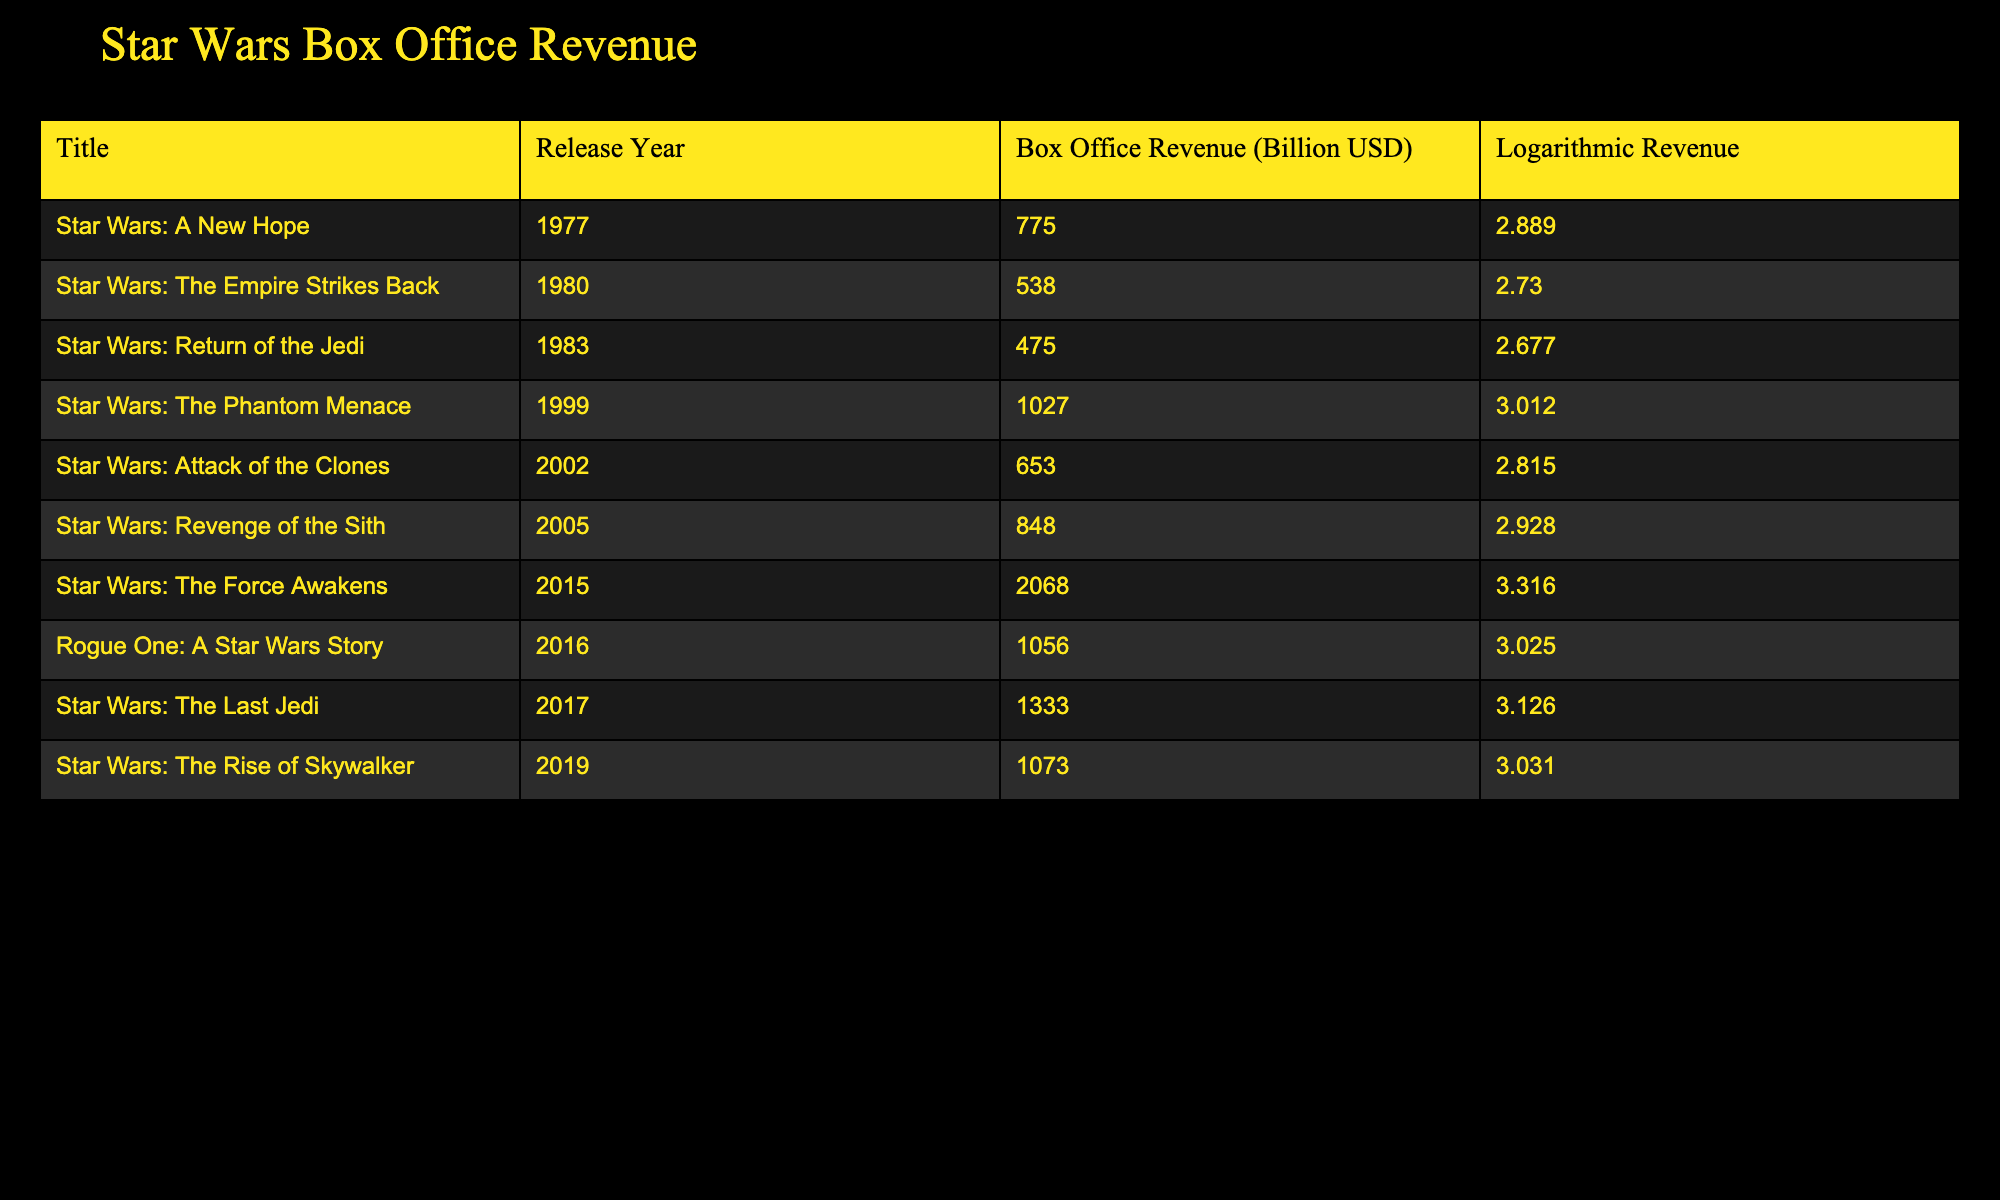What is the box office revenue of "Star Wars: The Force Awakens"? The table shows that the box office revenue of "Star Wars: The Force Awakens" is listed as 2068 billion USD.
Answer: 2068 billion USD Which movie had the lowest box office revenue? By examining the table, we see "Star Wars: Return of the Jedi" with a revenue of 475 billion USD is the lowest among the listed films.
Answer: Star Wars: Return of the Jedi What is the difference in box office revenue between "Star Wars: The Phantom Menace" and "Rogue One: A Star Wars Story"? The revenue for "Star Wars: The Phantom Menace" is 1027 billion USD, and "Rogue One: A Star Wars Story" is 1056 billion USD. Calculating the difference: 1056 - 1027 = 29 billion USD.
Answer: 29 billion USD Is "Star Wars: Attack of the Clones" more popular than "Star Wars: The Last Jedi" based on box office revenue? "Star Wars: Attack of the Clones" had a revenue of 653 billion USD, while "Star Wars: The Last Jedi" earned 1333 billion USD. Since 653 is less than 1333, the statement is false.
Answer: No What is the average box office revenue of all the listed Star Wars movies? Summing all the revenues: 775 + 538 + 475 + 1027 + 653 + 848 + 2068 + 1056 + 1333 + 1073 = 10348 billion USD. There are 10 movies, thus the average is 10348 / 10 = 1034.8 billion USD.
Answer: 1034.8 billion USD Which two movies had the highest logarithmic revenue values? Looking at the logarithmic revenue values, "Star Wars: The Force Awakens" has 3.316 and "Star Wars: The Last Jedi" has 3.126 as the two highest values.
Answer: "Star Wars: The Force Awakens" and "Star Wars: The Last Jedi" Was the box office revenue of "Star Wars: The Rise of Skywalker" greater than that of "Star Wars: A New Hope"? The revenue for "Star Wars: The Rise of Skywalker" is 1073 billion USD whereas "Star Wars: A New Hope" had 775 billion USD. Since 1073 is greater than 775, the answer is yes.
Answer: Yes What is the total box office revenue of all movies released after 2000? The revenues from movies after 2000 are: "Star Wars: Attack of the Clones" (653), "Star Wars: Revenge of the Sith" (848), "Star Wars: The Force Awakens" (2068), "Rogue One: A Star Wars Story" (1056), "Star Wars: The Last Jedi" (1333), and "Star Wars: The Rise of Skywalker" (1073). Summing these gives: 653 + 848 + 2068 + 1056 + 1333 + 1073 = 10631 billion USD.
Answer: 10631 billion USD 